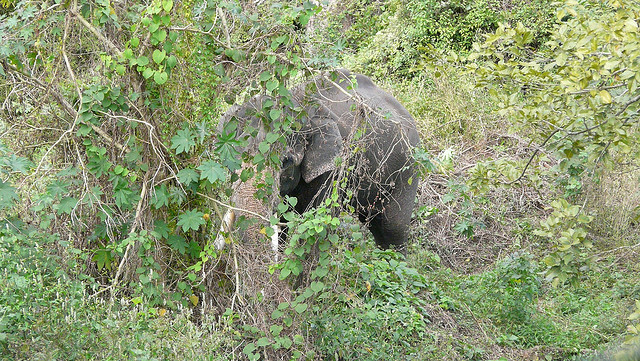<image>What is the danger illustrated by this photo? I don't know what the danger illustrated by the photo is. It could be an animal, possibly an elephant or something related to tusk. What is the danger illustrated by this photo? I don't know what danger is illustrated by this photo. It seems to be an elephant, but I can't determine the specific danger. 